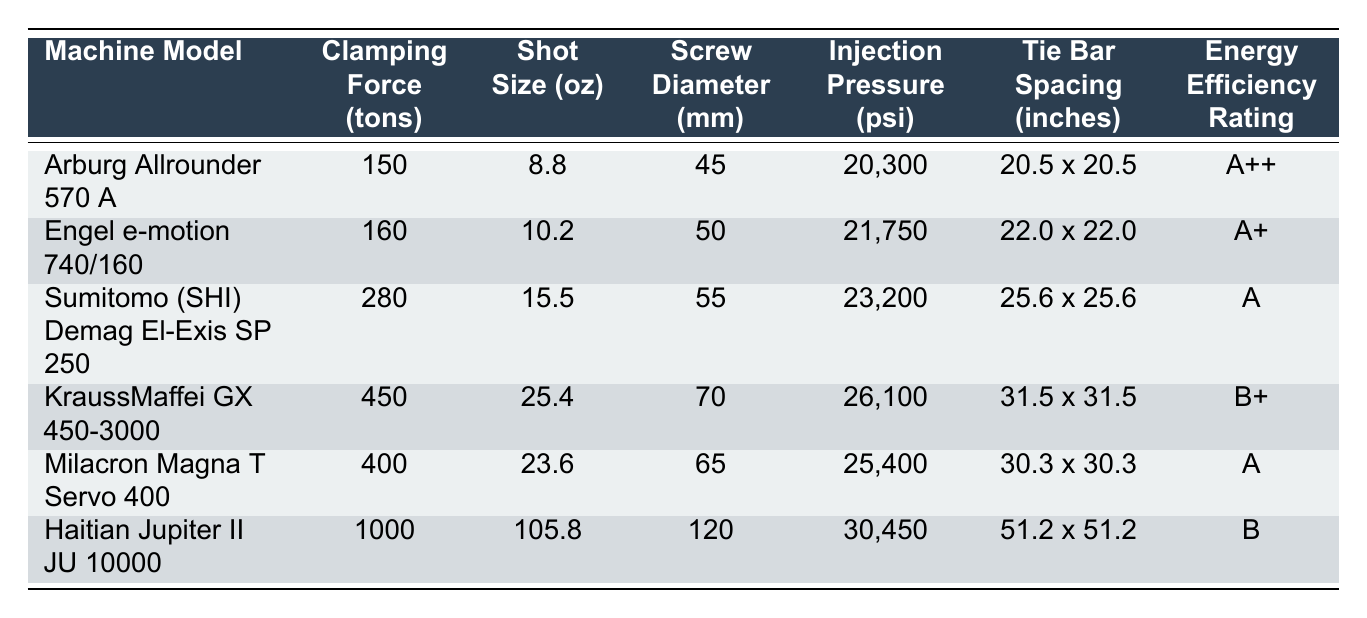What is the clamping force of the Engel e-motion 740/160? The clamping force value for the Engel e-motion 740/160 is located in the respective row and column dedicated to this information in the table. By looking at the second row, it shows a clamping force of 160 tons.
Answer: 160 tons Which machine has the highest shot size? By examining the shot size column across all rows, the machine with the highest shot size can be identified. The Haitian Jupiter II JU 10000 has a shot size of 105.8 oz, which is greater than the others.
Answer: Haitian Jupiter II JU 10000 Is the clamping force greater for the Milacron Magna T Servo 400 than for the Arburg Allrounder 570 A? To answer this yes or no question, we can compare the clamping forces of both machines directly. Milacron Magna T Servo 400 has a clamping force of 400 tons, while Arburg Allrounder 570 A has a clamping force of 150 tons. Since 400 is greater than 150, the answer is yes.
Answer: Yes What is the average injection pressure of the machines listed? To find the average, we need to sum the injection pressures of all machines and then divide by the number of machines. The sum of the pressures is 20,300 + 21,750 + 23,200 + 26,100 + 25,400 + 30,450 = 147,200 psi. Then, divide by 6 (the total number of machines), giving an average of 24,533.33 psi.
Answer: 24,533.33 psi How many machines have an energy efficiency rating of A or higher? We can count the machines with ratings A++, A+, or A listed in the energy efficiency rating column. Examining the table, there are 4 machines (Arburg Allrounder 570 A, Engel e-motion 740/160, Sumitomo El-Exis SP 250, and Milacron Magna T Servo 400) that meet this criterion.
Answer: 4 What is the difference in clamping force between the Haitian Jupiter II JU 10000 and the KraussMaffei GX 450-3000? The clamping force for Haitian Jupiter II JU 10000 is 1000 tons and for KraussMaffei GX 450-3000 it is 450 tons. The difference can be calculated by subtracting 450 from 1000, which equals 550 tons.
Answer: 550 tons Which machine has the largest tie bar spacing? By checking the tie bar spacing column, we find the measurements listed for each machine. The largest value is found for the Haitian Jupiter II JU 10000 with 51.2 x 51.2 inches, which exceeds the others in the table.
Answer: Haitian Jupiter II JU 10000 Is there a machine with a screw diameter of 70 mm that has an energy efficiency rating of A? We can check the screw diameter and the corresponding energy efficiency rating for the KraussMaffei GX 450-3000, which has a screw diameter of 70 mm and an energy efficiency rating of B+. Therefore, the answer to this question is no.
Answer: No 